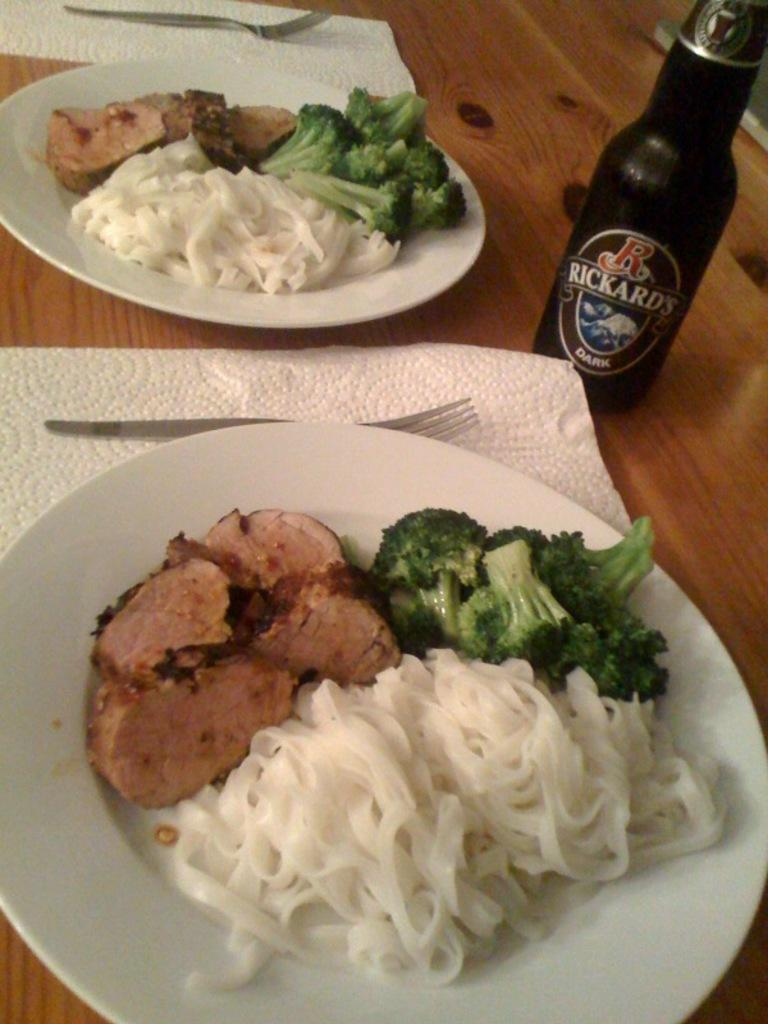What is on the table in the image? There is a plate on the table in the image. What is on the plate? There is food on the plate, along with forks and tissue paper. What color is the bottle in the image? There is a black color bottle in the image. In which direction is the desk facing in the image? There is no desk present in the image. 